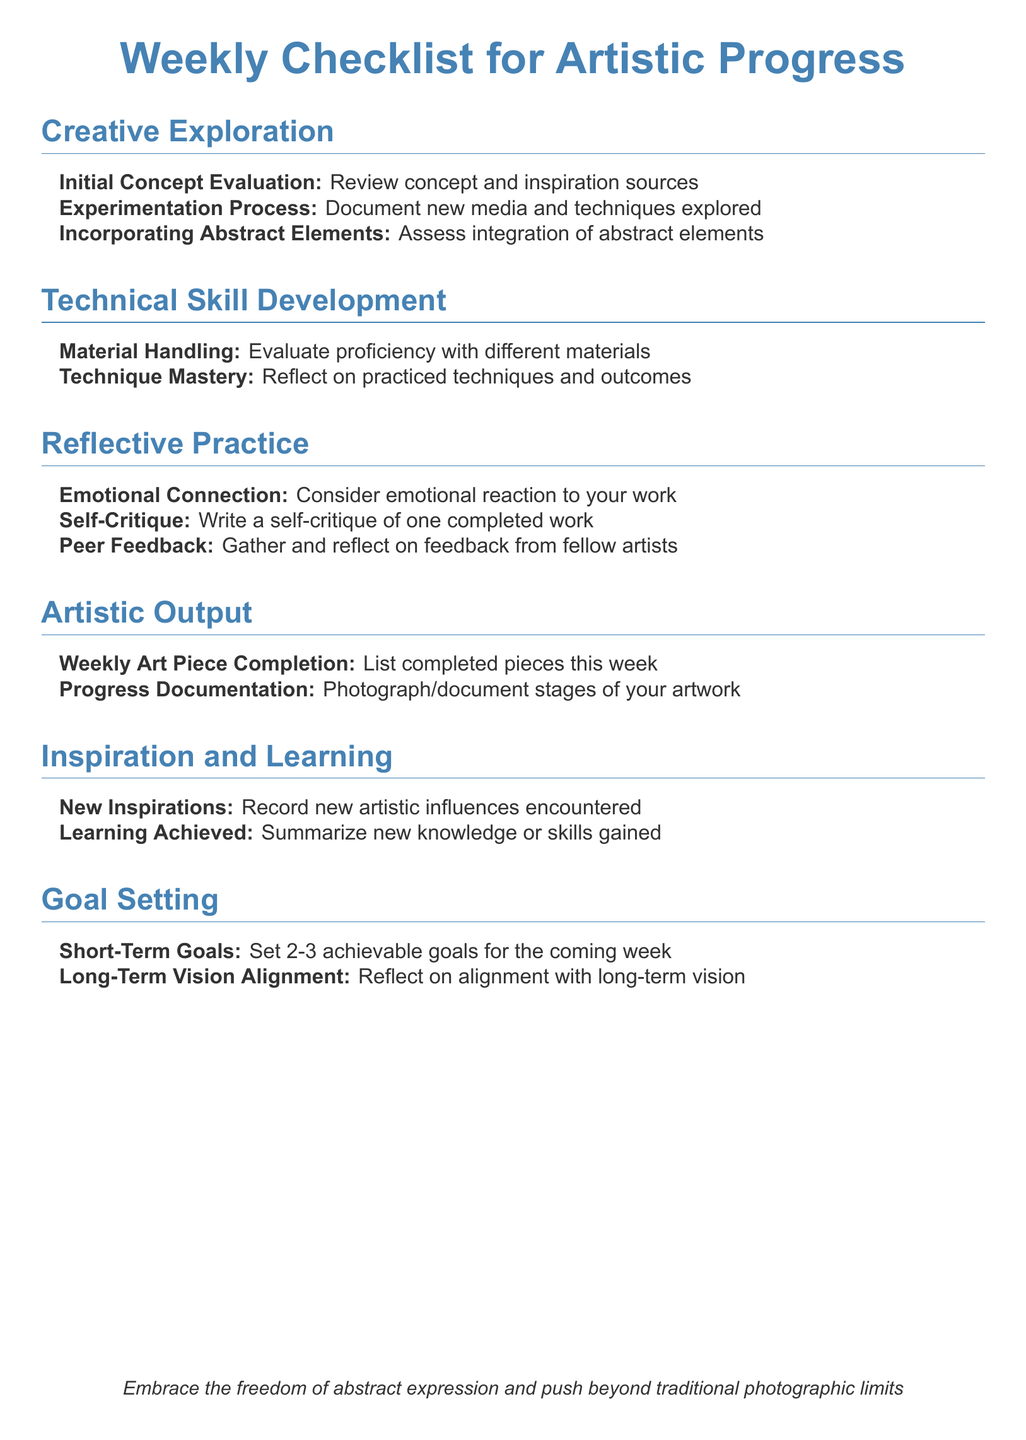what is the main focus of the checklist? The main focus of the checklist is to guide artists in evaluating their artistic progress weekly.
Answer: artistic progress how many sections are in the checklist? The document has several sections, each addressing different aspects of artistic evaluation. Counting the headings provides the total number.
Answer: six what should be documented during the experimentation process? The experimentation process requires documentation of newly explored media and techniques.
Answer: new media and techniques what is encouraged in the emotional connection evaluation? The emotional connection evaluation focuses on considering the emotional reaction to the artist's work.
Answer: emotional reaction how many achievable goals should be set for the coming week? The checklist encourages setting a specific number of achievable goals for the next week.
Answer: 2-3 what is suggested for short-term and long-term vision reflection? Reflection should consider the alignment of goals with the artist's long-term vision.
Answer: alignment with long-term vision how are peer feedbacks to be handled according to the document? The document advises to gather and reflect on feedback from fellow artists.
Answer: reflect on feedback what should be recorded under new inspirations? The section on new inspirations asks to document new artistic influences encountered.
Answer: artistic influences 